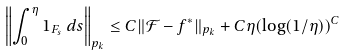Convert formula to latex. <formula><loc_0><loc_0><loc_500><loc_500>\left \| \int _ { 0 } ^ { \eta } 1 _ { F _ { s } } \, d s \right \| _ { p _ { k } } \leq C \| \mathcal { F } - f ^ { * } \| _ { p _ { k } } + C \eta ( \log ( 1 / \eta ) ) ^ { C }</formula> 